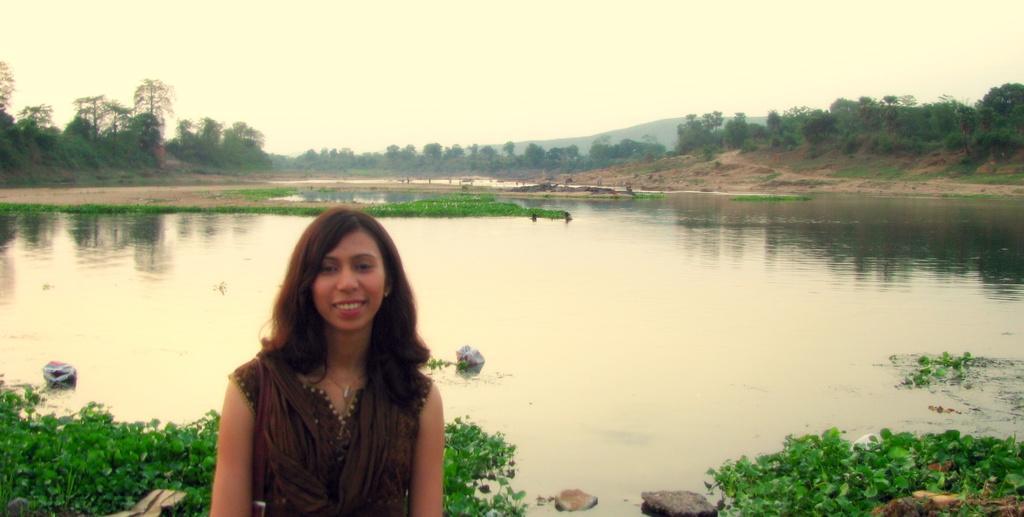Could you give a brief overview of what you see in this image? In this image we can see a woman wearing brown color dress is standing here and smiling. Here we can see plants floating on the water, stones, trees, hills and the plain sky in the background. 